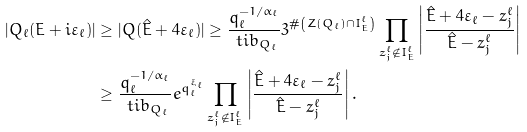Convert formula to latex. <formula><loc_0><loc_0><loc_500><loc_500>| Q _ { \ell } ( E + i \varepsilon _ { \ell } ) | & \geq | Q ( \hat { E } + 4 \varepsilon _ { \ell } ) | \geq \frac { q _ { \ell } ^ { - 1 / \alpha _ { \ell } } } { \ t i { b } _ { Q _ { \ell } } } 3 ^ { \# \left ( Z ( Q _ { \ell } ) \cap I _ { E } ^ { \ell } \right ) } \prod _ { z ^ { \ell } _ { j } \notin I ^ { \ell } _ { E } } \left | \frac { \hat { E } + 4 \varepsilon _ { \ell } - z ^ { \ell } _ { j } } { \hat { E } - z ^ { \ell } _ { j } } \right | \\ & \geq \frac { q _ { \ell } ^ { - 1 / \alpha _ { \ell } } } { \ t i { b } _ { Q _ { \ell } } } e ^ { q _ { \ell } ^ { \xi _ { \ell } } } \prod _ { z ^ { \ell } _ { j } \notin I ^ { \ell } _ { E } } \left | \frac { \hat { E } + 4 \varepsilon _ { \ell } - z ^ { \ell } _ { j } } { \hat { E } - z ^ { \ell } _ { j } } \right | .</formula> 